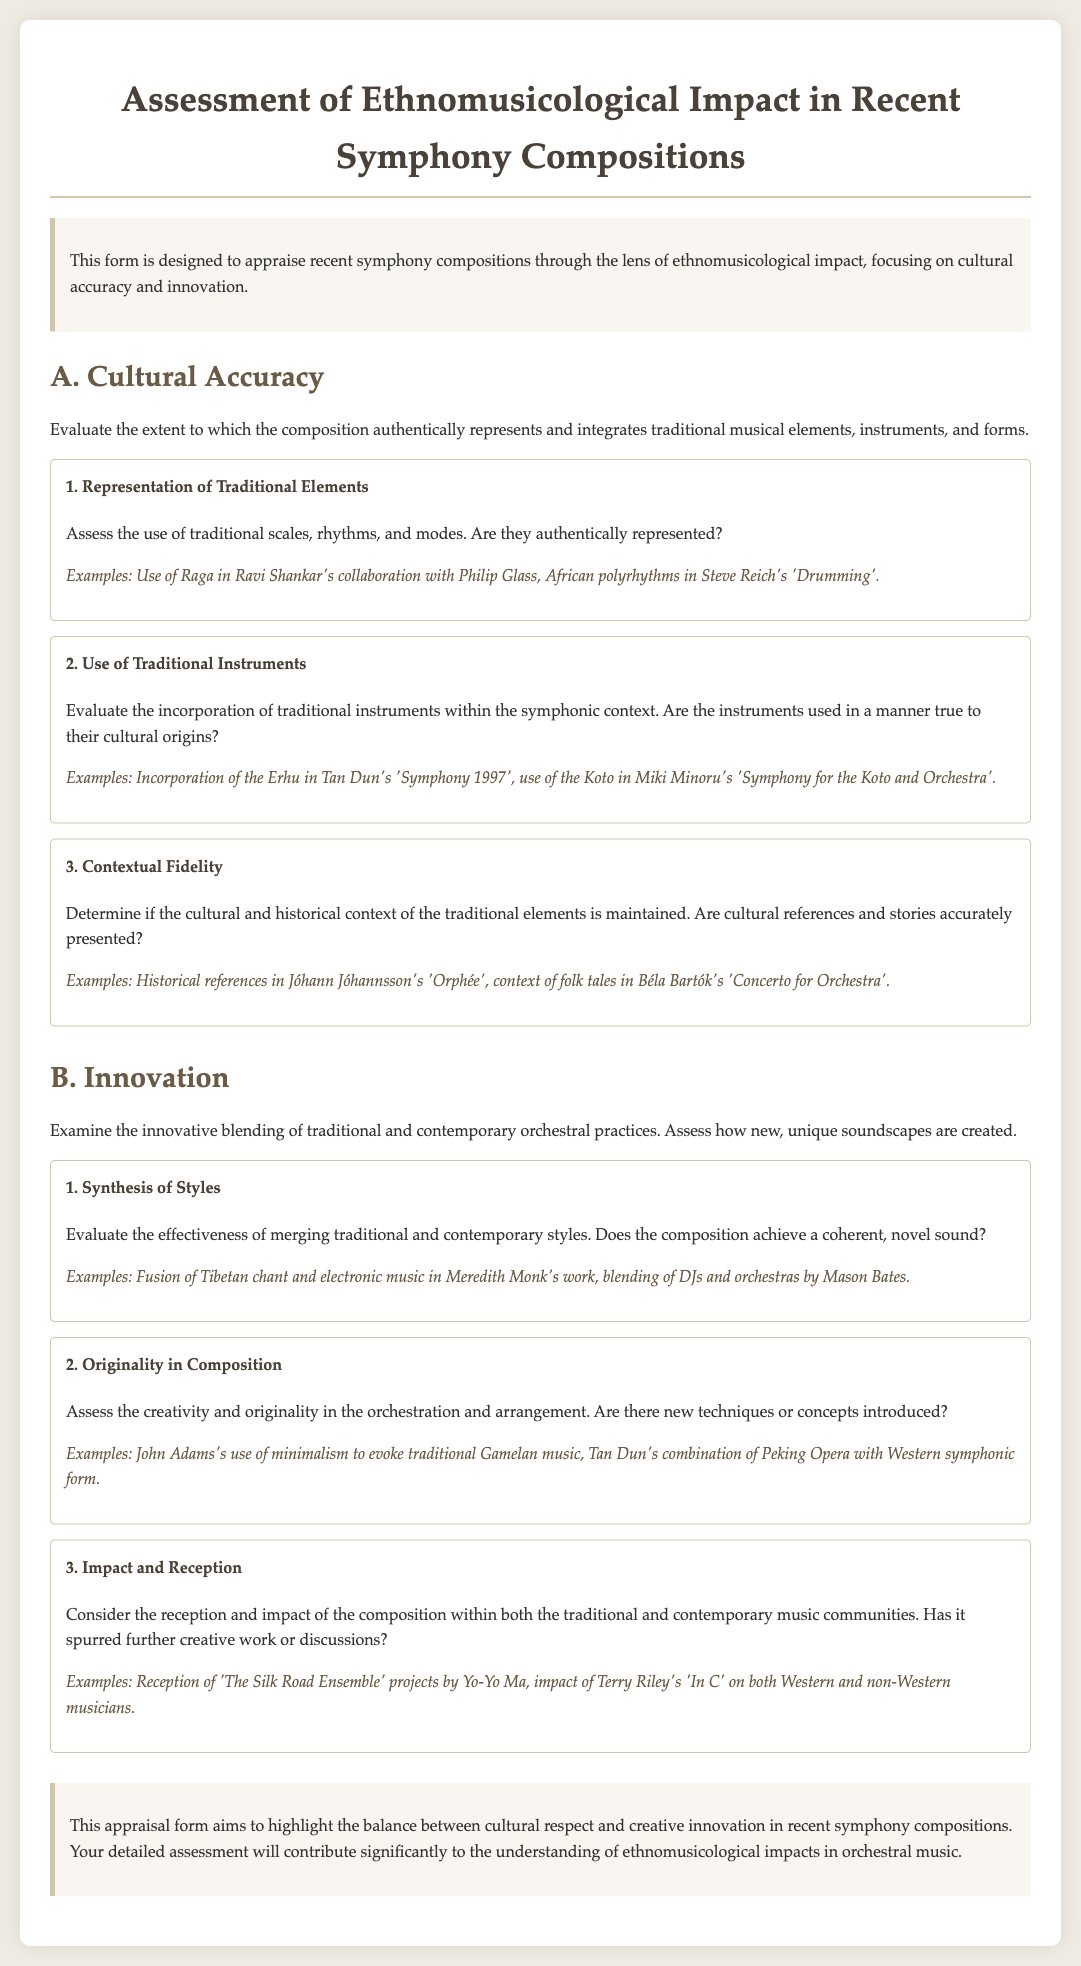what is the title of the document? The title of the document is prominently displayed at the top of the page.
Answer: Assessment of Ethnomusicological Impact in Recent Symphony Compositions what are the two main categories assessed in the document? The document clearly lists the categories that are being evaluated in the appraisal form.
Answer: Cultural Accuracy and Innovation how many criteria are there under the category of Cultural Accuracy? The document outlines the specific criteria under each category.
Answer: Three what example is given for the representation of traditional elements? Each criterion provides specific examples that illustrate the point being made, including this one.
Answer: Use of Raga in Ravi Shankar's collaboration with Philip Glass which composition incorporates the Erhu? The document lists specific compositions that exemplify the use of traditional instruments.
Answer: Tan Dun's 'Symphony 1997' what does the criterion 'Synthesis of Styles' assess? The document explains the focus of each criterion under the Innovation category.
Answer: Effectiveness of merging traditional and contemporary styles who is mentioned as having an impact on both Western and non-Western musicians? The document provides examples of notable figures and their contributions in the context of impact and reception.
Answer: Terry Riley how does the document describe the overall goal of the appraisal? The conclusion summarizes the purpose of the document and what the appraisal seeks to highlight.
Answer: Highlight the balance between cultural respect and creative innovation 